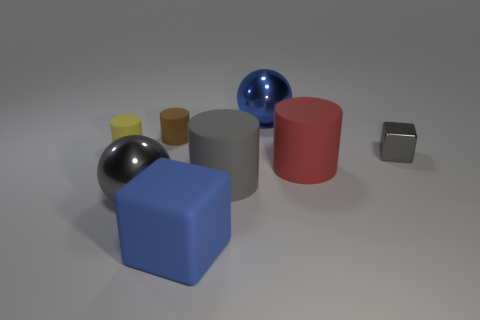Are there fewer rubber objects that are in front of the brown cylinder than rubber things that are left of the small gray shiny object?
Provide a short and direct response. Yes. How many green things are matte spheres or large shiny objects?
Provide a succinct answer. 0. Are there an equal number of gray cylinders to the left of the shiny cube and blue metallic balls?
Provide a short and direct response. Yes. What number of things are large gray metallic things or big spheres that are behind the small gray object?
Make the answer very short. 2. Is there a big cylinder made of the same material as the brown object?
Give a very brief answer. Yes. What color is the other large metallic thing that is the same shape as the large blue shiny thing?
Your response must be concise. Gray. Does the large blue sphere have the same material as the cube to the left of the shiny block?
Provide a succinct answer. No. The large blue object that is behind the big gray object that is on the left side of the large blue matte block is what shape?
Keep it short and to the point. Sphere. Do the metallic object that is on the right side of the blue ball and the blue matte object have the same size?
Make the answer very short. No. What number of other objects are the same shape as the small brown thing?
Your response must be concise. 3. 